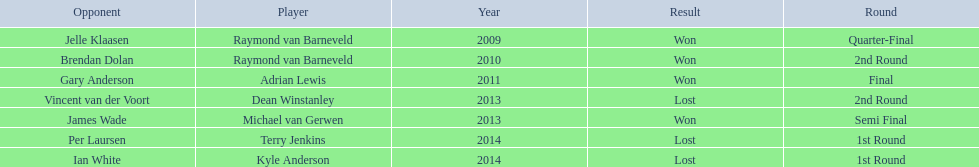Who were the players in 2014? Terry Jenkins, Kyle Anderson. Did they win or lose? Per Laursen. 